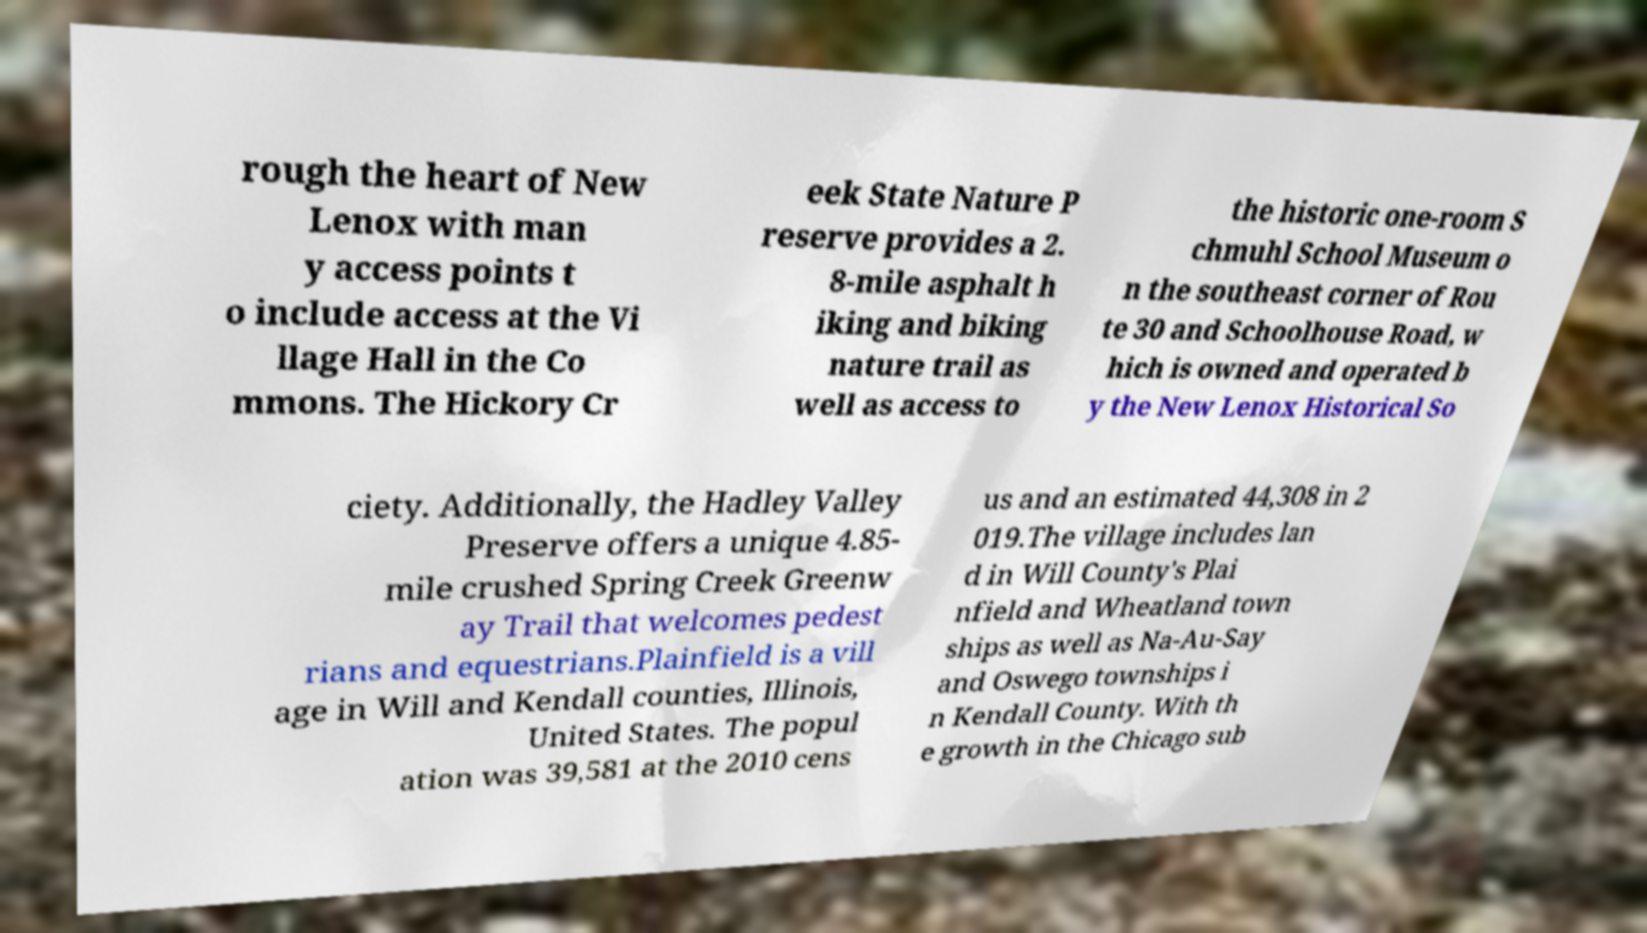Can you read and provide the text displayed in the image?This photo seems to have some interesting text. Can you extract and type it out for me? rough the heart of New Lenox with man y access points t o include access at the Vi llage Hall in the Co mmons. The Hickory Cr eek State Nature P reserve provides a 2. 8-mile asphalt h iking and biking nature trail as well as access to the historic one-room S chmuhl School Museum o n the southeast corner of Rou te 30 and Schoolhouse Road, w hich is owned and operated b y the New Lenox Historical So ciety. Additionally, the Hadley Valley Preserve offers a unique 4.85- mile crushed Spring Creek Greenw ay Trail that welcomes pedest rians and equestrians.Plainfield is a vill age in Will and Kendall counties, Illinois, United States. The popul ation was 39,581 at the 2010 cens us and an estimated 44,308 in 2 019.The village includes lan d in Will County's Plai nfield and Wheatland town ships as well as Na-Au-Say and Oswego townships i n Kendall County. With th e growth in the Chicago sub 